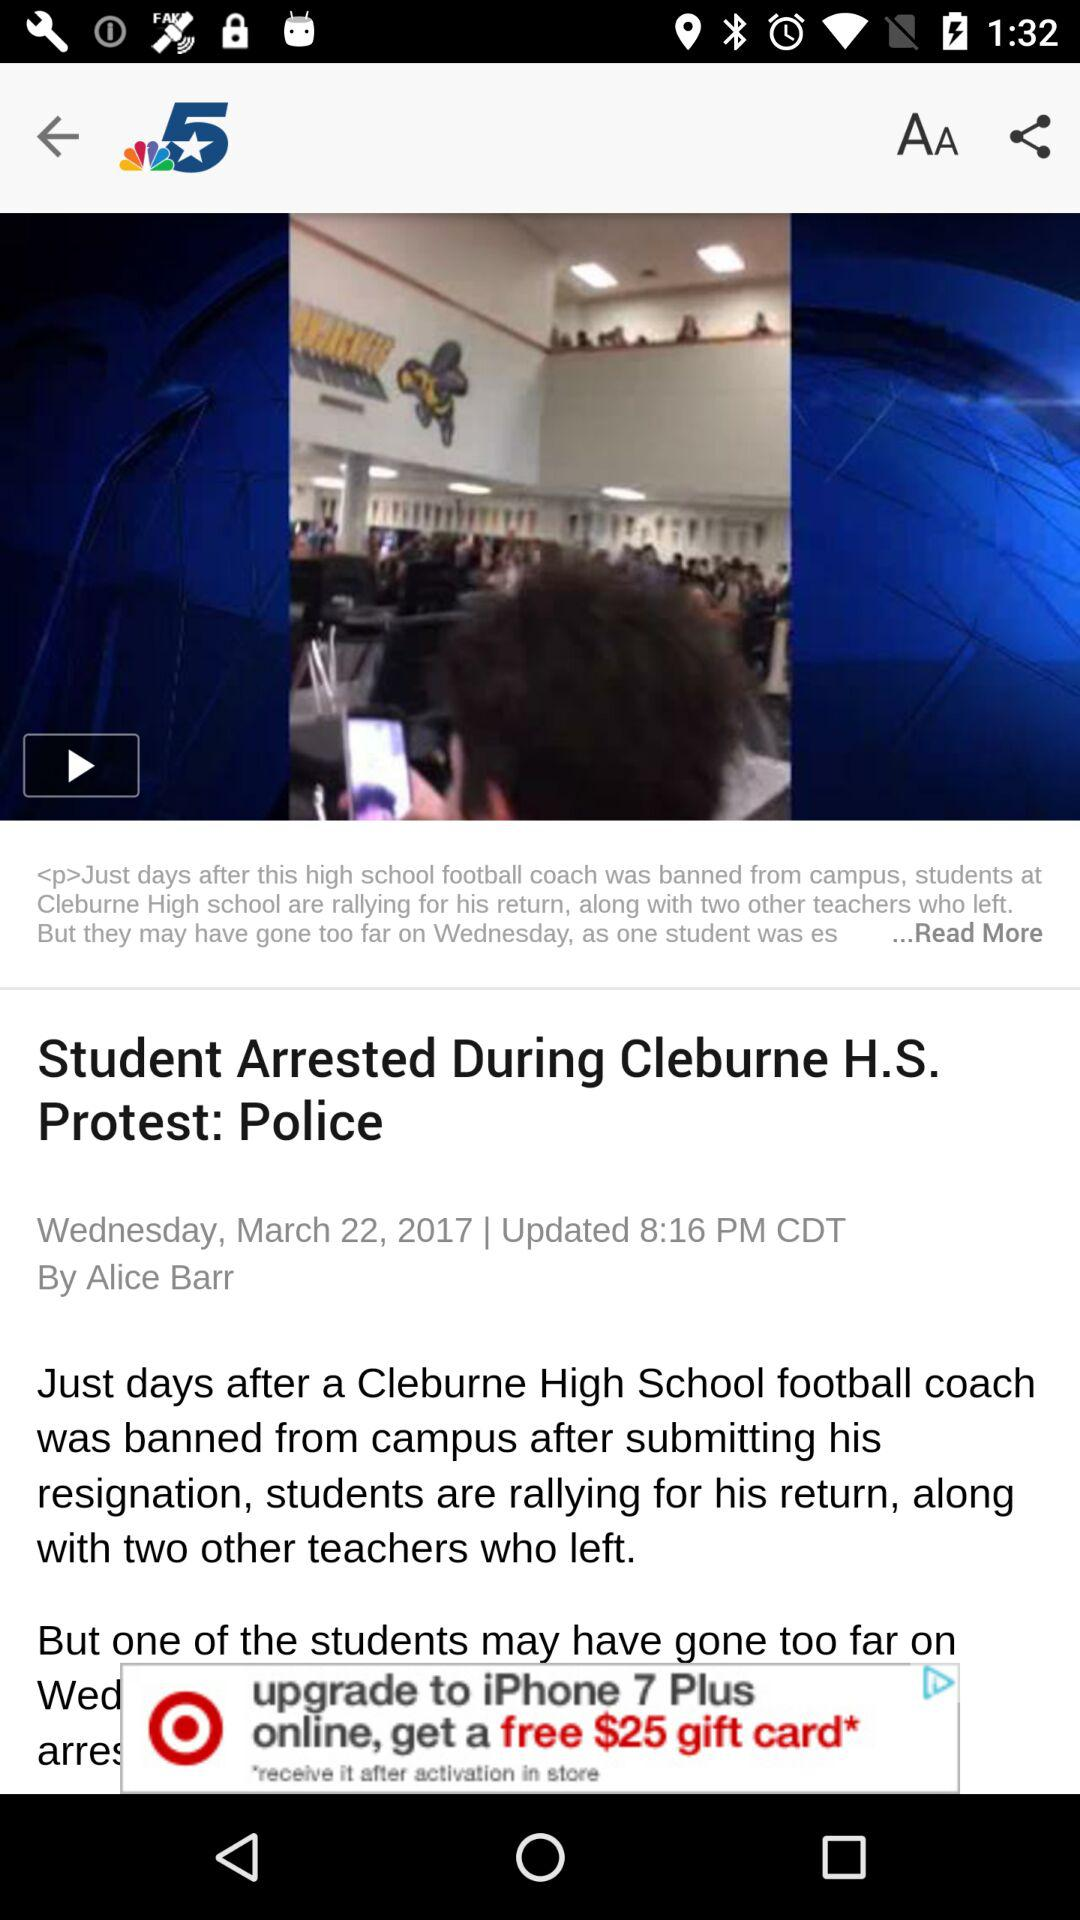What is the title of the news? The title of the news is "Student Arrested During Cleburne H.S. Protest: Police". 